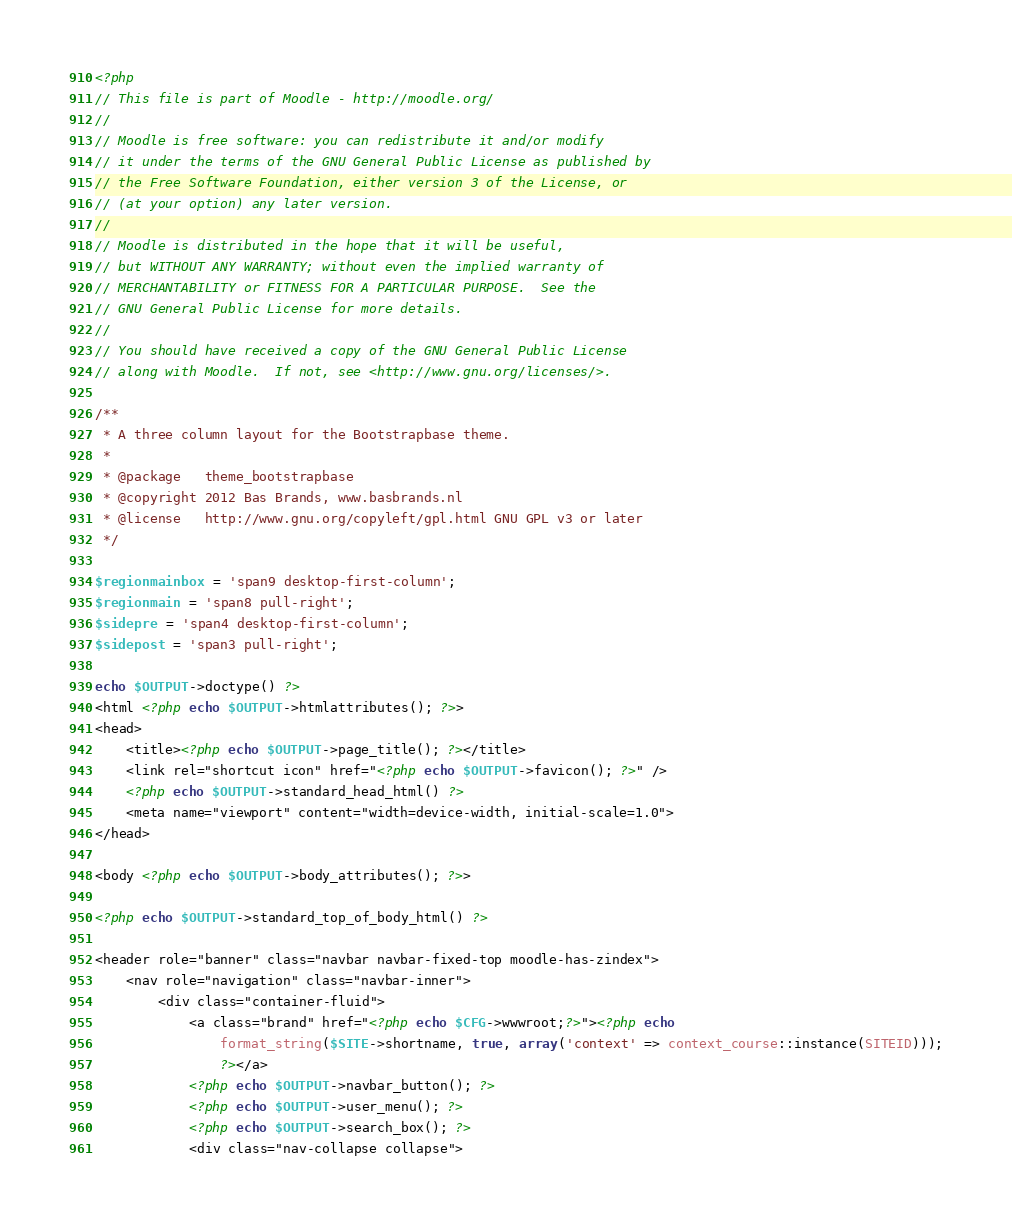<code> <loc_0><loc_0><loc_500><loc_500><_PHP_><?php
// This file is part of Moodle - http://moodle.org/
//
// Moodle is free software: you can redistribute it and/or modify
// it under the terms of the GNU General Public License as published by
// the Free Software Foundation, either version 3 of the License, or
// (at your option) any later version.
//
// Moodle is distributed in the hope that it will be useful,
// but WITHOUT ANY WARRANTY; without even the implied warranty of
// MERCHANTABILITY or FITNESS FOR A PARTICULAR PURPOSE.  See the
// GNU General Public License for more details.
//
// You should have received a copy of the GNU General Public License
// along with Moodle.  If not, see <http://www.gnu.org/licenses/>.

/**
 * A three column layout for the Bootstrapbase theme.
 *
 * @package   theme_bootstrapbase
 * @copyright 2012 Bas Brands, www.basbrands.nl
 * @license   http://www.gnu.org/copyleft/gpl.html GNU GPL v3 or later
 */

$regionmainbox = 'span9 desktop-first-column';
$regionmain = 'span8 pull-right';
$sidepre = 'span4 desktop-first-column';
$sidepost = 'span3 pull-right';

echo $OUTPUT->doctype() ?>
<html <?php echo $OUTPUT->htmlattributes(); ?>>
<head>
    <title><?php echo $OUTPUT->page_title(); ?></title>
    <link rel="shortcut icon" href="<?php echo $OUTPUT->favicon(); ?>" />
    <?php echo $OUTPUT->standard_head_html() ?>
    <meta name="viewport" content="width=device-width, initial-scale=1.0">
</head>

<body <?php echo $OUTPUT->body_attributes(); ?>>

<?php echo $OUTPUT->standard_top_of_body_html() ?>

<header role="banner" class="navbar navbar-fixed-top moodle-has-zindex">
    <nav role="navigation" class="navbar-inner">
        <div class="container-fluid">
            <a class="brand" href="<?php echo $CFG->wwwroot;?>"><?php echo
                format_string($SITE->shortname, true, array('context' => context_course::instance(SITEID)));
                ?></a>
            <?php echo $OUTPUT->navbar_button(); ?>
            <?php echo $OUTPUT->user_menu(); ?>
            <?php echo $OUTPUT->search_box(); ?>
            <div class="nav-collapse collapse"></code> 